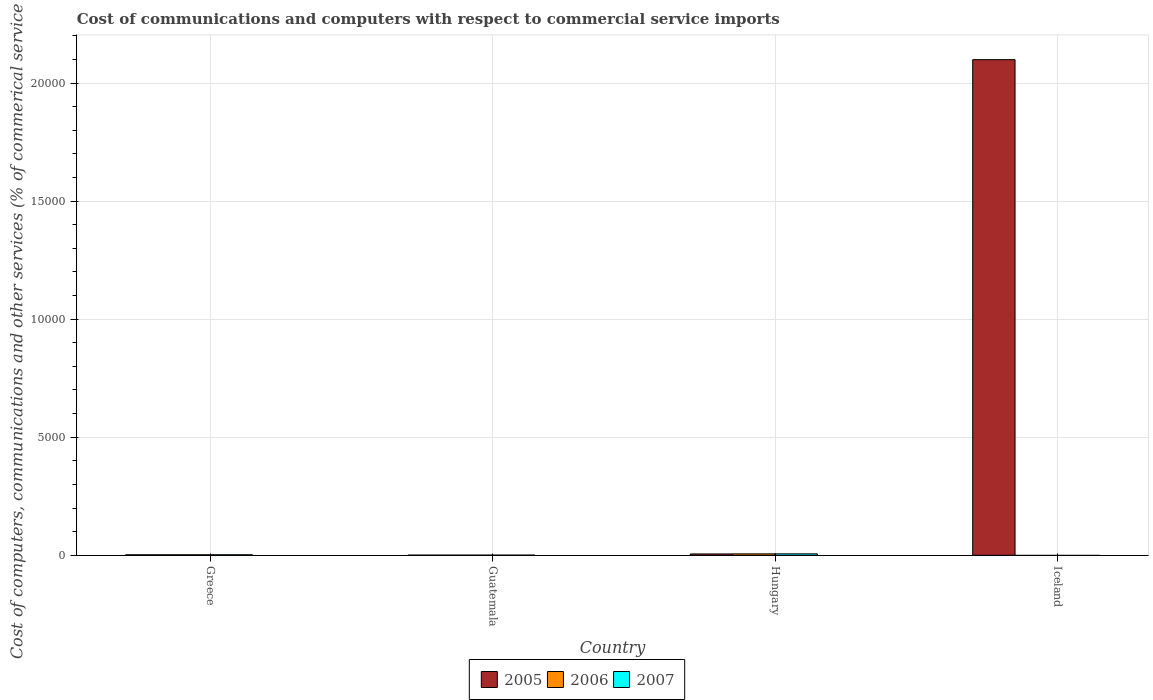Are the number of bars per tick equal to the number of legend labels?
Offer a terse response. No. How many bars are there on the 2nd tick from the left?
Offer a terse response. 3. In how many cases, is the number of bars for a given country not equal to the number of legend labels?
Give a very brief answer. 1. What is the cost of communications and computers in 2007 in Guatemala?
Your response must be concise. 6.34. Across all countries, what is the maximum cost of communications and computers in 2007?
Keep it short and to the point. 60.46. Across all countries, what is the minimum cost of communications and computers in 2005?
Offer a terse response. 5.89. In which country was the cost of communications and computers in 2007 maximum?
Your answer should be very brief. Hungary. What is the total cost of communications and computers in 2007 in the graph?
Make the answer very short. 88.07. What is the difference between the cost of communications and computers in 2005 in Greece and that in Iceland?
Offer a terse response. -2.10e+04. What is the difference between the cost of communications and computers in 2005 in Greece and the cost of communications and computers in 2006 in Iceland?
Ensure brevity in your answer.  19.54. What is the average cost of communications and computers in 2007 per country?
Give a very brief answer. 22.02. What is the difference between the cost of communications and computers of/in 2006 and cost of communications and computers of/in 2007 in Guatemala?
Your answer should be very brief. 0.25. In how many countries, is the cost of communications and computers in 2006 greater than 21000 %?
Provide a short and direct response. 0. What is the ratio of the cost of communications and computers in 2007 in Greece to that in Guatemala?
Provide a short and direct response. 3.36. Is the cost of communications and computers in 2006 in Guatemala less than that in Hungary?
Make the answer very short. Yes. Is the difference between the cost of communications and computers in 2006 in Greece and Guatemala greater than the difference between the cost of communications and computers in 2007 in Greece and Guatemala?
Provide a succinct answer. No. What is the difference between the highest and the second highest cost of communications and computers in 2007?
Provide a succinct answer. 39.19. What is the difference between the highest and the lowest cost of communications and computers in 2006?
Offer a very short reply. 59.67. In how many countries, is the cost of communications and computers in 2006 greater than the average cost of communications and computers in 2006 taken over all countries?
Give a very brief answer. 1. How many bars are there?
Keep it short and to the point. 10. How many countries are there in the graph?
Keep it short and to the point. 4. What is the difference between two consecutive major ticks on the Y-axis?
Ensure brevity in your answer.  5000. Are the values on the major ticks of Y-axis written in scientific E-notation?
Your answer should be very brief. No. Does the graph contain grids?
Your response must be concise. Yes. Where does the legend appear in the graph?
Provide a short and direct response. Bottom center. What is the title of the graph?
Ensure brevity in your answer.  Cost of communications and computers with respect to commercial service imports. What is the label or title of the X-axis?
Offer a terse response. Country. What is the label or title of the Y-axis?
Provide a succinct answer. Cost of computers, communications and other services (% of commerical service exports). What is the Cost of computers, communications and other services (% of commerical service exports) of 2005 in Greece?
Make the answer very short. 19.54. What is the Cost of computers, communications and other services (% of commerical service exports) in 2006 in Greece?
Make the answer very short. 20.81. What is the Cost of computers, communications and other services (% of commerical service exports) of 2007 in Greece?
Your answer should be very brief. 21.27. What is the Cost of computers, communications and other services (% of commerical service exports) of 2005 in Guatemala?
Provide a succinct answer. 5.89. What is the Cost of computers, communications and other services (% of commerical service exports) of 2006 in Guatemala?
Your answer should be compact. 6.58. What is the Cost of computers, communications and other services (% of commerical service exports) of 2007 in Guatemala?
Make the answer very short. 6.34. What is the Cost of computers, communications and other services (% of commerical service exports) of 2005 in Hungary?
Offer a terse response. 56.61. What is the Cost of computers, communications and other services (% of commerical service exports) in 2006 in Hungary?
Your response must be concise. 59.67. What is the Cost of computers, communications and other services (% of commerical service exports) of 2007 in Hungary?
Your response must be concise. 60.46. What is the Cost of computers, communications and other services (% of commerical service exports) of 2005 in Iceland?
Give a very brief answer. 2.10e+04. Across all countries, what is the maximum Cost of computers, communications and other services (% of commerical service exports) in 2005?
Provide a succinct answer. 2.10e+04. Across all countries, what is the maximum Cost of computers, communications and other services (% of commerical service exports) of 2006?
Provide a succinct answer. 59.67. Across all countries, what is the maximum Cost of computers, communications and other services (% of commerical service exports) of 2007?
Offer a terse response. 60.46. Across all countries, what is the minimum Cost of computers, communications and other services (% of commerical service exports) in 2005?
Ensure brevity in your answer.  5.89. What is the total Cost of computers, communications and other services (% of commerical service exports) of 2005 in the graph?
Your answer should be compact. 2.11e+04. What is the total Cost of computers, communications and other services (% of commerical service exports) in 2006 in the graph?
Ensure brevity in your answer.  87.06. What is the total Cost of computers, communications and other services (% of commerical service exports) of 2007 in the graph?
Your response must be concise. 88.07. What is the difference between the Cost of computers, communications and other services (% of commerical service exports) in 2005 in Greece and that in Guatemala?
Keep it short and to the point. 13.65. What is the difference between the Cost of computers, communications and other services (% of commerical service exports) of 2006 in Greece and that in Guatemala?
Your answer should be very brief. 14.23. What is the difference between the Cost of computers, communications and other services (% of commerical service exports) of 2007 in Greece and that in Guatemala?
Your response must be concise. 14.93. What is the difference between the Cost of computers, communications and other services (% of commerical service exports) of 2005 in Greece and that in Hungary?
Offer a very short reply. -37.06. What is the difference between the Cost of computers, communications and other services (% of commerical service exports) in 2006 in Greece and that in Hungary?
Offer a terse response. -38.86. What is the difference between the Cost of computers, communications and other services (% of commerical service exports) in 2007 in Greece and that in Hungary?
Provide a succinct answer. -39.19. What is the difference between the Cost of computers, communications and other services (% of commerical service exports) of 2005 in Greece and that in Iceland?
Your answer should be very brief. -2.10e+04. What is the difference between the Cost of computers, communications and other services (% of commerical service exports) in 2005 in Guatemala and that in Hungary?
Keep it short and to the point. -50.71. What is the difference between the Cost of computers, communications and other services (% of commerical service exports) in 2006 in Guatemala and that in Hungary?
Provide a succinct answer. -53.09. What is the difference between the Cost of computers, communications and other services (% of commerical service exports) of 2007 in Guatemala and that in Hungary?
Ensure brevity in your answer.  -54.13. What is the difference between the Cost of computers, communications and other services (% of commerical service exports) in 2005 in Guatemala and that in Iceland?
Keep it short and to the point. -2.10e+04. What is the difference between the Cost of computers, communications and other services (% of commerical service exports) in 2005 in Hungary and that in Iceland?
Offer a very short reply. -2.09e+04. What is the difference between the Cost of computers, communications and other services (% of commerical service exports) in 2005 in Greece and the Cost of computers, communications and other services (% of commerical service exports) in 2006 in Guatemala?
Offer a terse response. 12.96. What is the difference between the Cost of computers, communications and other services (% of commerical service exports) of 2005 in Greece and the Cost of computers, communications and other services (% of commerical service exports) of 2007 in Guatemala?
Keep it short and to the point. 13.21. What is the difference between the Cost of computers, communications and other services (% of commerical service exports) in 2006 in Greece and the Cost of computers, communications and other services (% of commerical service exports) in 2007 in Guatemala?
Ensure brevity in your answer.  14.47. What is the difference between the Cost of computers, communications and other services (% of commerical service exports) in 2005 in Greece and the Cost of computers, communications and other services (% of commerical service exports) in 2006 in Hungary?
Offer a terse response. -40.13. What is the difference between the Cost of computers, communications and other services (% of commerical service exports) of 2005 in Greece and the Cost of computers, communications and other services (% of commerical service exports) of 2007 in Hungary?
Provide a short and direct response. -40.92. What is the difference between the Cost of computers, communications and other services (% of commerical service exports) in 2006 in Greece and the Cost of computers, communications and other services (% of commerical service exports) in 2007 in Hungary?
Ensure brevity in your answer.  -39.65. What is the difference between the Cost of computers, communications and other services (% of commerical service exports) of 2005 in Guatemala and the Cost of computers, communications and other services (% of commerical service exports) of 2006 in Hungary?
Ensure brevity in your answer.  -53.78. What is the difference between the Cost of computers, communications and other services (% of commerical service exports) of 2005 in Guatemala and the Cost of computers, communications and other services (% of commerical service exports) of 2007 in Hungary?
Offer a terse response. -54.57. What is the difference between the Cost of computers, communications and other services (% of commerical service exports) in 2006 in Guatemala and the Cost of computers, communications and other services (% of commerical service exports) in 2007 in Hungary?
Keep it short and to the point. -53.88. What is the average Cost of computers, communications and other services (% of commerical service exports) in 2005 per country?
Offer a very short reply. 5268.14. What is the average Cost of computers, communications and other services (% of commerical service exports) in 2006 per country?
Ensure brevity in your answer.  21.77. What is the average Cost of computers, communications and other services (% of commerical service exports) in 2007 per country?
Keep it short and to the point. 22.02. What is the difference between the Cost of computers, communications and other services (% of commerical service exports) in 2005 and Cost of computers, communications and other services (% of commerical service exports) in 2006 in Greece?
Offer a very short reply. -1.27. What is the difference between the Cost of computers, communications and other services (% of commerical service exports) of 2005 and Cost of computers, communications and other services (% of commerical service exports) of 2007 in Greece?
Your response must be concise. -1.73. What is the difference between the Cost of computers, communications and other services (% of commerical service exports) of 2006 and Cost of computers, communications and other services (% of commerical service exports) of 2007 in Greece?
Your answer should be compact. -0.46. What is the difference between the Cost of computers, communications and other services (% of commerical service exports) of 2005 and Cost of computers, communications and other services (% of commerical service exports) of 2006 in Guatemala?
Offer a terse response. -0.69. What is the difference between the Cost of computers, communications and other services (% of commerical service exports) in 2005 and Cost of computers, communications and other services (% of commerical service exports) in 2007 in Guatemala?
Ensure brevity in your answer.  -0.44. What is the difference between the Cost of computers, communications and other services (% of commerical service exports) of 2006 and Cost of computers, communications and other services (% of commerical service exports) of 2007 in Guatemala?
Provide a short and direct response. 0.25. What is the difference between the Cost of computers, communications and other services (% of commerical service exports) of 2005 and Cost of computers, communications and other services (% of commerical service exports) of 2006 in Hungary?
Your response must be concise. -3.06. What is the difference between the Cost of computers, communications and other services (% of commerical service exports) in 2005 and Cost of computers, communications and other services (% of commerical service exports) in 2007 in Hungary?
Offer a terse response. -3.86. What is the difference between the Cost of computers, communications and other services (% of commerical service exports) in 2006 and Cost of computers, communications and other services (% of commerical service exports) in 2007 in Hungary?
Offer a very short reply. -0.79. What is the ratio of the Cost of computers, communications and other services (% of commerical service exports) in 2005 in Greece to that in Guatemala?
Keep it short and to the point. 3.32. What is the ratio of the Cost of computers, communications and other services (% of commerical service exports) in 2006 in Greece to that in Guatemala?
Ensure brevity in your answer.  3.16. What is the ratio of the Cost of computers, communications and other services (% of commerical service exports) of 2007 in Greece to that in Guatemala?
Offer a very short reply. 3.36. What is the ratio of the Cost of computers, communications and other services (% of commerical service exports) of 2005 in Greece to that in Hungary?
Keep it short and to the point. 0.35. What is the ratio of the Cost of computers, communications and other services (% of commerical service exports) of 2006 in Greece to that in Hungary?
Offer a terse response. 0.35. What is the ratio of the Cost of computers, communications and other services (% of commerical service exports) of 2007 in Greece to that in Hungary?
Provide a short and direct response. 0.35. What is the ratio of the Cost of computers, communications and other services (% of commerical service exports) in 2005 in Greece to that in Iceland?
Provide a succinct answer. 0. What is the ratio of the Cost of computers, communications and other services (% of commerical service exports) in 2005 in Guatemala to that in Hungary?
Your answer should be very brief. 0.1. What is the ratio of the Cost of computers, communications and other services (% of commerical service exports) of 2006 in Guatemala to that in Hungary?
Offer a very short reply. 0.11. What is the ratio of the Cost of computers, communications and other services (% of commerical service exports) in 2007 in Guatemala to that in Hungary?
Your answer should be compact. 0.1. What is the ratio of the Cost of computers, communications and other services (% of commerical service exports) of 2005 in Hungary to that in Iceland?
Your response must be concise. 0. What is the difference between the highest and the second highest Cost of computers, communications and other services (% of commerical service exports) in 2005?
Keep it short and to the point. 2.09e+04. What is the difference between the highest and the second highest Cost of computers, communications and other services (% of commerical service exports) of 2006?
Keep it short and to the point. 38.86. What is the difference between the highest and the second highest Cost of computers, communications and other services (% of commerical service exports) in 2007?
Provide a short and direct response. 39.19. What is the difference between the highest and the lowest Cost of computers, communications and other services (% of commerical service exports) in 2005?
Offer a terse response. 2.10e+04. What is the difference between the highest and the lowest Cost of computers, communications and other services (% of commerical service exports) in 2006?
Provide a succinct answer. 59.67. What is the difference between the highest and the lowest Cost of computers, communications and other services (% of commerical service exports) of 2007?
Provide a succinct answer. 60.46. 